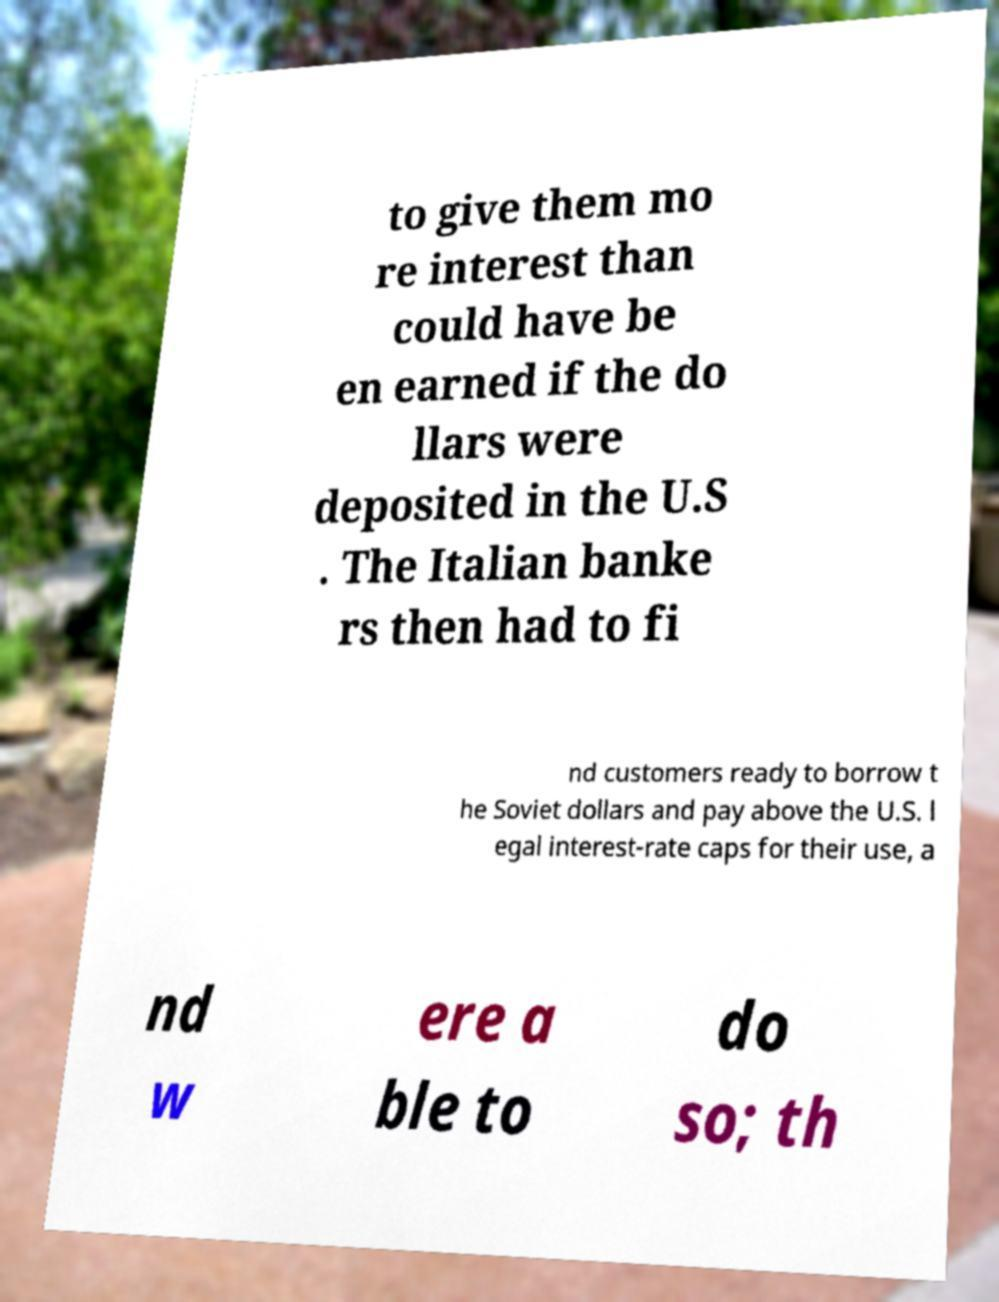Can you read and provide the text displayed in the image?This photo seems to have some interesting text. Can you extract and type it out for me? to give them mo re interest than could have be en earned if the do llars were deposited in the U.S . The Italian banke rs then had to fi nd customers ready to borrow t he Soviet dollars and pay above the U.S. l egal interest-rate caps for their use, a nd w ere a ble to do so; th 